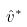<formula> <loc_0><loc_0><loc_500><loc_500>\hat { v } ^ { * }</formula> 